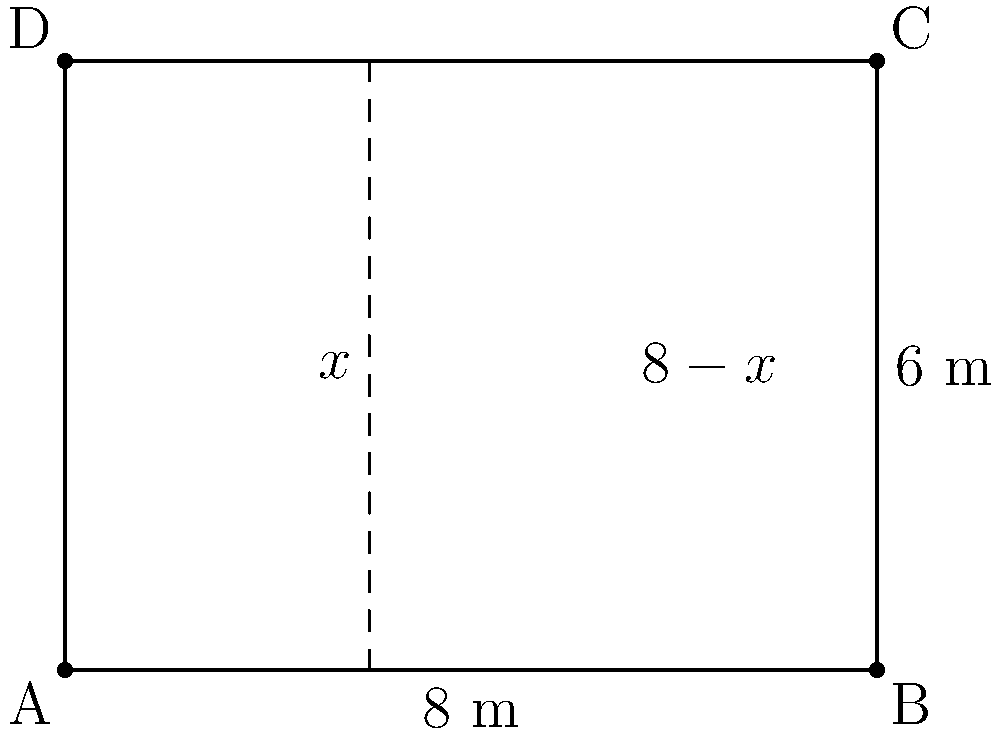Your next album promotion requires a rectangular billboard. The total area of the billboard is 48 square meters, with a width of 8 meters. You want to divide the billboard vertically into two sections: one for your image and one for the album information. If the area of your image section is represented by $x$ meters, what is the width of the album information section? Let's approach this step-by-step:

1) The total area of the billboard is 48 square meters.
2) The width of the billboard is 8 meters.
3) To find the height, we can use the area formula: 
   Area = width × height
   48 = 8 × height
   height = 48 ÷ 8 = 6 meters

4) Let $x$ be the width of your image section.
5) The width of the album information section will be $(8-x)$ meters.

6) The areas of these sections can be expressed as:
   Your image section: $6x$ square meters
   Album info section: $6(8-x)$ square meters

7) The total area is the sum of these sections:
   $6x + 6(8-x) = 48$

8) Simplify the equation:
   $6x + 48 - 6x = 48$
   $48 = 48$

9) This equation is true for any value of $x$. However, we're asked about the width of the album information section, which is $(8-x)$.

Therefore, the width of the album information section is $(8-x)$ meters.
Answer: $8-x$ meters 